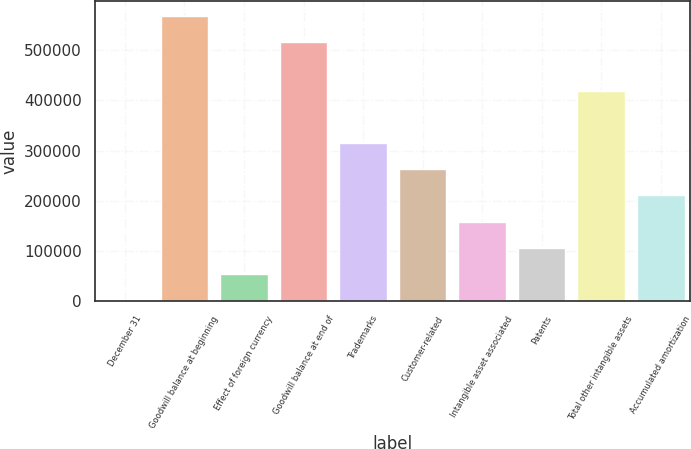<chart> <loc_0><loc_0><loc_500><loc_500><bar_chart><fcel>December 31<fcel>Goodwill balance at beginning<fcel>Effect of foreign currency<fcel>Goodwill balance at end of<fcel>Trademarks<fcel>Customer-related<fcel>Intangible asset associated<fcel>Patents<fcel>Total other intangible assets<fcel>Accumulated amortization<nl><fcel>2011<fcel>568957<fcel>54223.3<fcel>516745<fcel>315285<fcel>263072<fcel>158648<fcel>106436<fcel>419709<fcel>210860<nl></chart> 